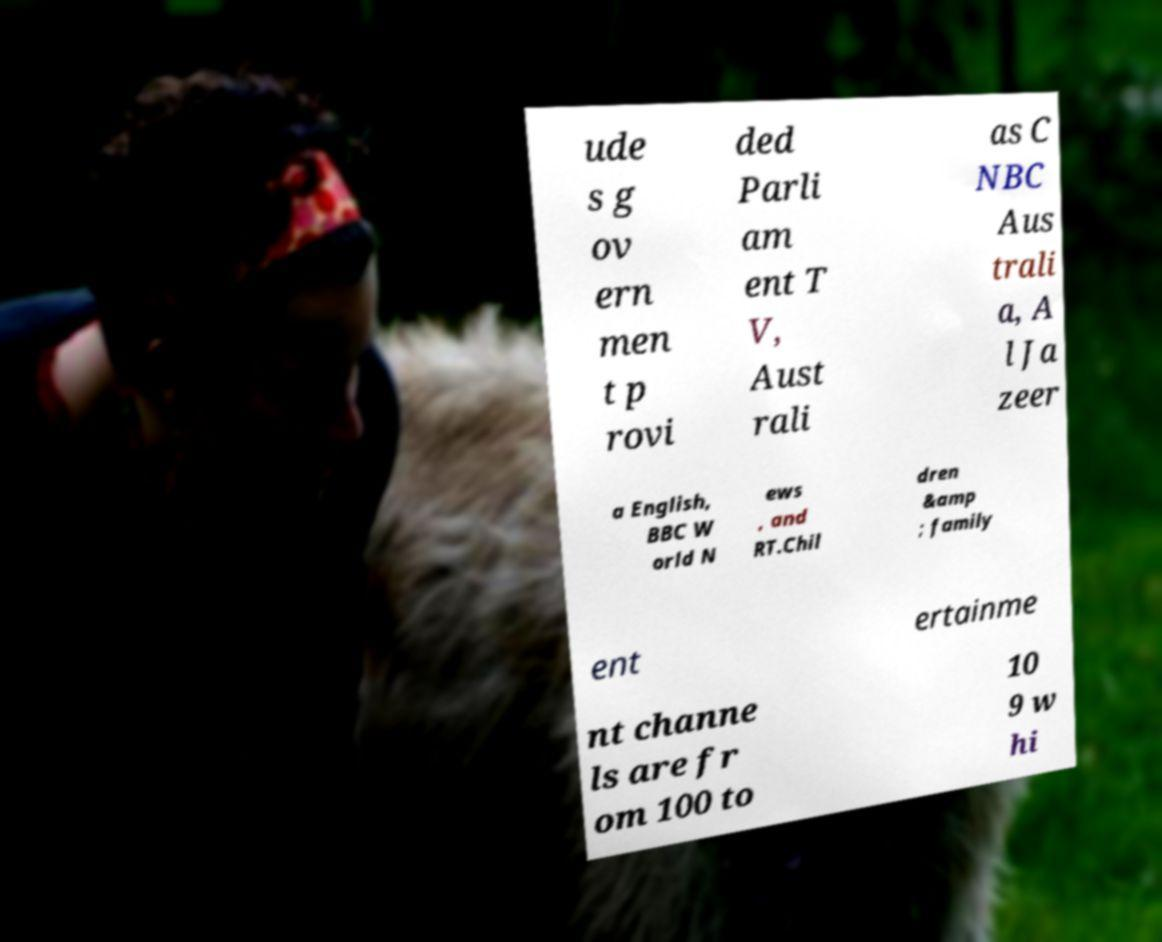What messages or text are displayed in this image? I need them in a readable, typed format. ude s g ov ern men t p rovi ded Parli am ent T V, Aust rali as C NBC Aus trali a, A l Ja zeer a English, BBC W orld N ews , and RT.Chil dren &amp ; family ent ertainme nt channe ls are fr om 100 to 10 9 w hi 